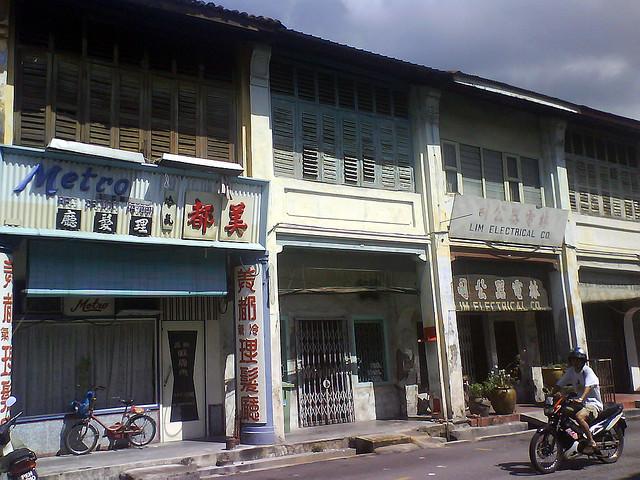How many people is there?
Be succinct. 1. How many bicycles are in the image?
Short answer required. 1. Is this a Chinese writing?
Write a very short answer. Yes. What state is pictured somewhere on the building?
Give a very brief answer. None. Which way can you not turn?
Be succinct. Right. Are the people dressed in warm weather clothes?
Short answer required. Yes. 